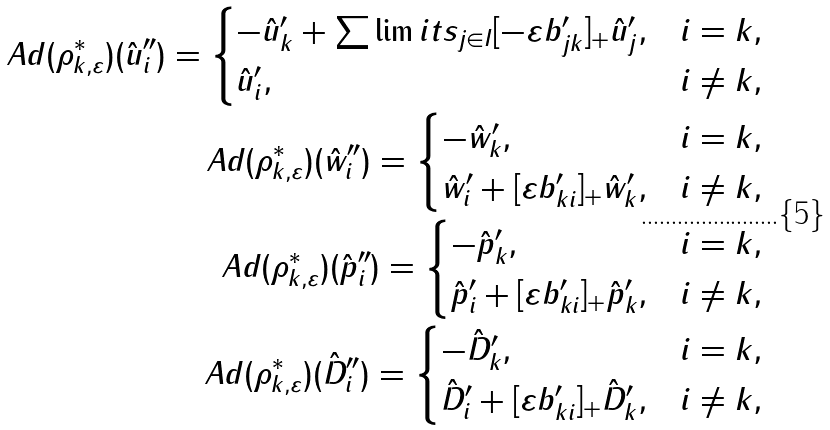<formula> <loc_0><loc_0><loc_500><loc_500>A d ( \rho ^ { * } _ { k , \varepsilon } ) ( \hat { u } ^ { \prime \prime } _ { i } ) = \begin{cases} - \hat { u } ^ { \prime } _ { k } + \sum \lim i t s _ { j \in I } [ - \varepsilon b ^ { \prime } _ { j k } ] _ { + } \hat { u } ^ { \prime } _ { j } , & i = k , \\ \hat { u } ^ { \prime } _ { i } , & i \neq k , \end{cases} \\ A d ( \rho ^ { * } _ { k , \varepsilon } ) ( \hat { w } ^ { \prime \prime } _ { i } ) = \begin{cases} - \hat { w } ^ { \prime } _ { k } , & i = k , \\ \hat { w } ^ { \prime } _ { i } + [ \varepsilon b ^ { \prime } _ { k i } ] _ { + } \hat { w } ^ { \prime } _ { k } , & i \neq k , \end{cases} \\ A d ( \rho ^ { * } _ { k , \varepsilon } ) ( \hat { p } ^ { \prime \prime } _ { i } ) = \begin{cases} - \hat { p } ^ { \prime } _ { k } , & i = k , \\ \hat { p } ^ { \prime } _ { i } + [ \varepsilon b ^ { \prime } _ { k i } ] _ { + } \hat { p } ^ { \prime } _ { k } , & i \neq k , \end{cases} \\ A d ( \rho ^ { * } _ { k , \varepsilon } ) ( \hat { D } ^ { \prime \prime } _ { i } ) = \begin{cases} - \hat { D } ^ { \prime } _ { k } , & i = k , \\ \hat { D } ^ { \prime } _ { i } + [ \varepsilon b ^ { \prime } _ { k i } ] _ { + } \hat { D } ^ { \prime } _ { k } , & i \neq k , \end{cases}</formula> 